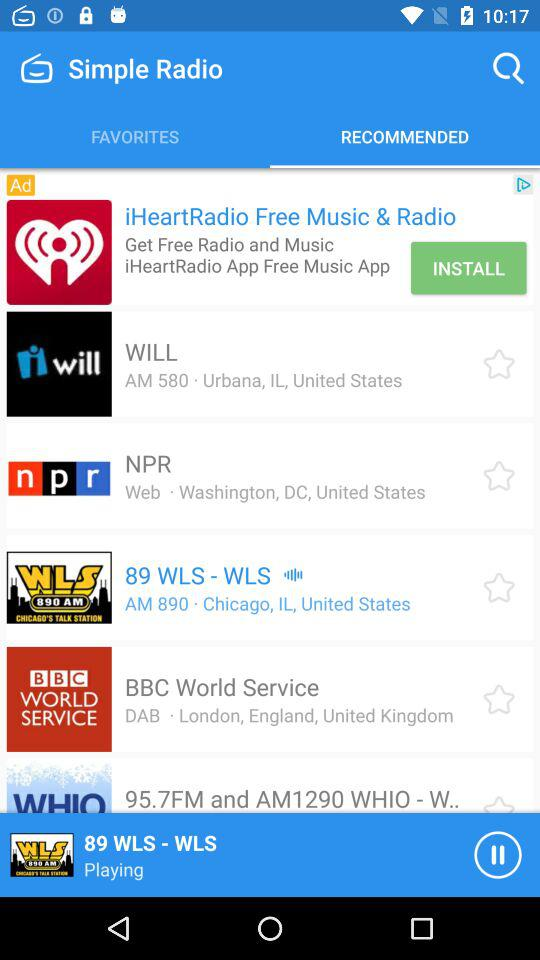Which tab is selected? The selected tab is "RECOMMENDED". 